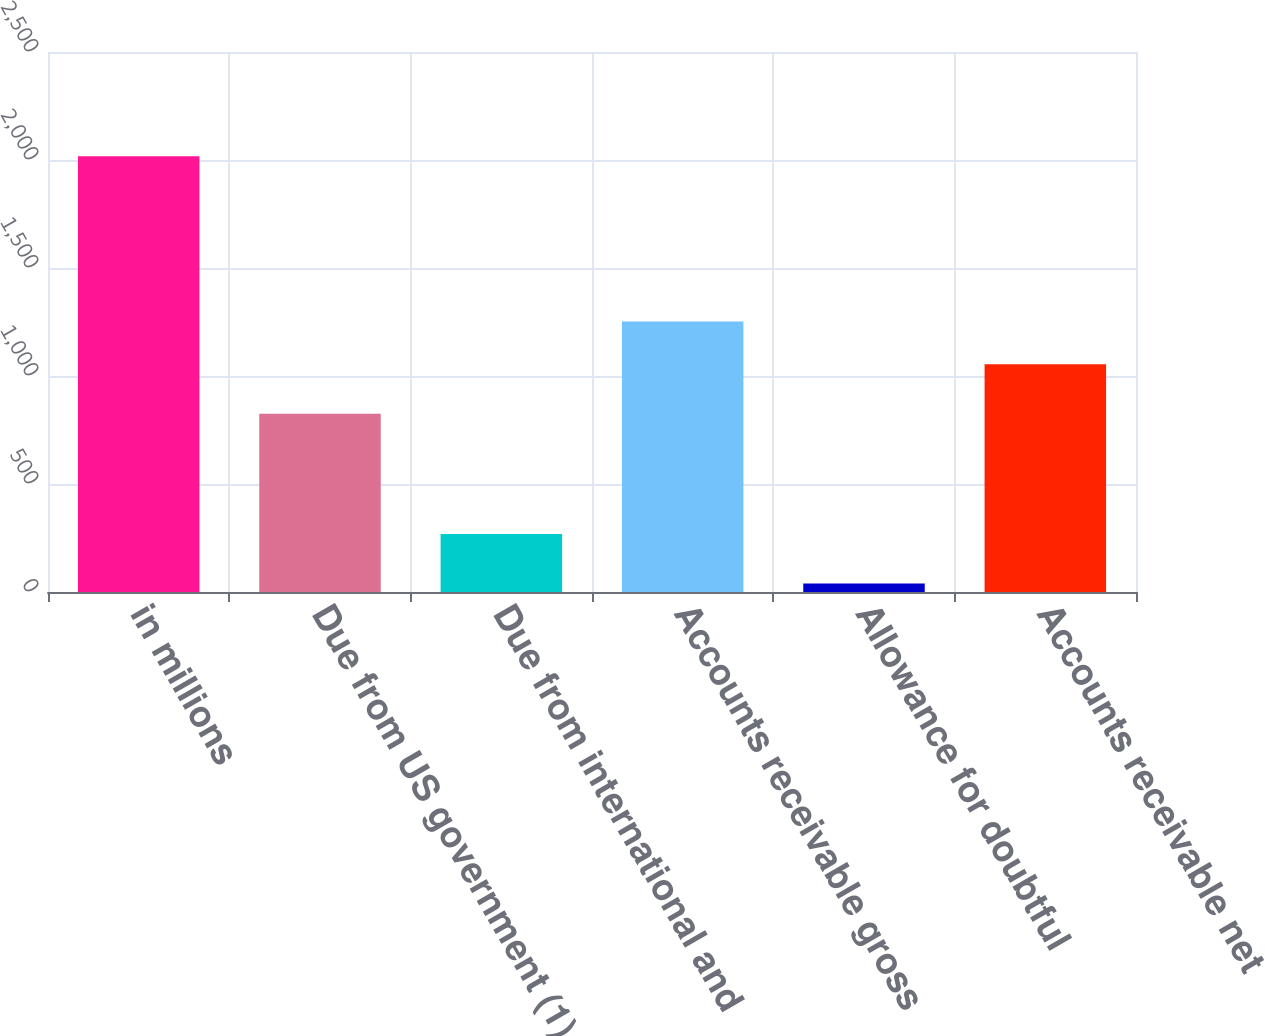<chart> <loc_0><loc_0><loc_500><loc_500><bar_chart><fcel>in millions<fcel>Due from US government (1)<fcel>Due from international and<fcel>Accounts receivable gross<fcel>Allowance for doubtful<fcel>Accounts receivable net<nl><fcel>2017<fcel>825<fcel>268<fcel>1251.8<fcel>39<fcel>1054<nl></chart> 